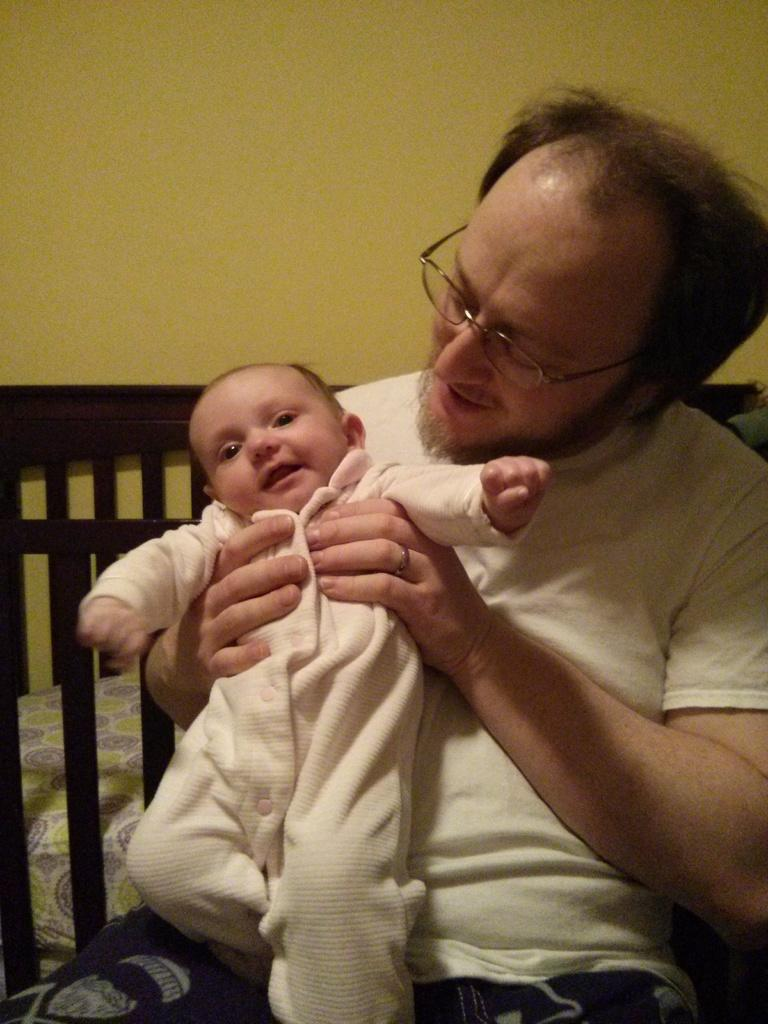Who is present in the image? There is a man in the image. What is the man wearing? The man is wearing a white t-shirt. Where is the man sitting? The man is sitting on a sofa. What is the man doing with the baby? The man is carrying a baby in his hand and looking at the baby. What can be seen in the background of the image? There is a wall in the background of the image. What type of volcano can be seen erupting in the background of the image? There is no volcano present in the image; it features a man sitting on a sofa, carrying a baby, and wearing a white t-shirt, with a wall in the background. 